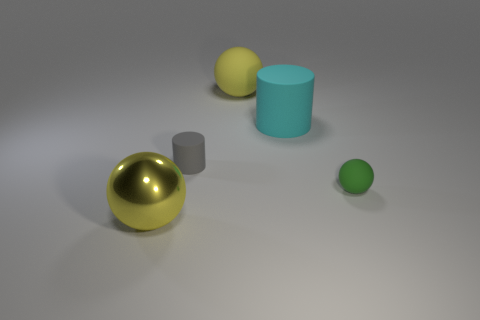Is there a yellow metallic thing of the same shape as the tiny gray matte object? Yes, there is a yellow metallic sphere in the image which has the same spherical shape as the tiny gray matte one. These objects appear to be part of a still life scene with a simple arrangement of various geometric shapes and materials. 